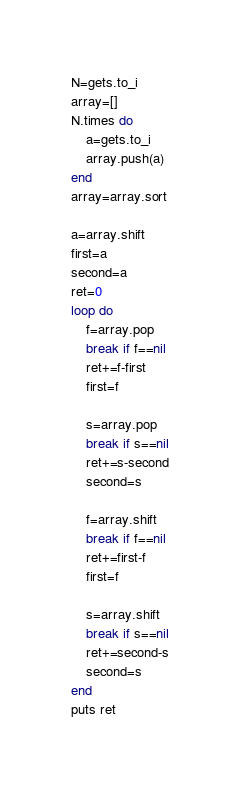<code> <loc_0><loc_0><loc_500><loc_500><_Ruby_>N=gets.to_i
array=[]
N.times do
    a=gets.to_i
    array.push(a)
end
array=array.sort

a=array.shift
first=a
second=a
ret=0
loop do
    f=array.pop
    break if f==nil
    ret+=f-first
    first=f

    s=array.pop
    break if s==nil
    ret+=s-second
    second=s

    f=array.shift
    break if f==nil
    ret+=first-f
    first=f

    s=array.shift
    break if s==nil
    ret+=second-s
    second=s
end
puts ret

</code> 